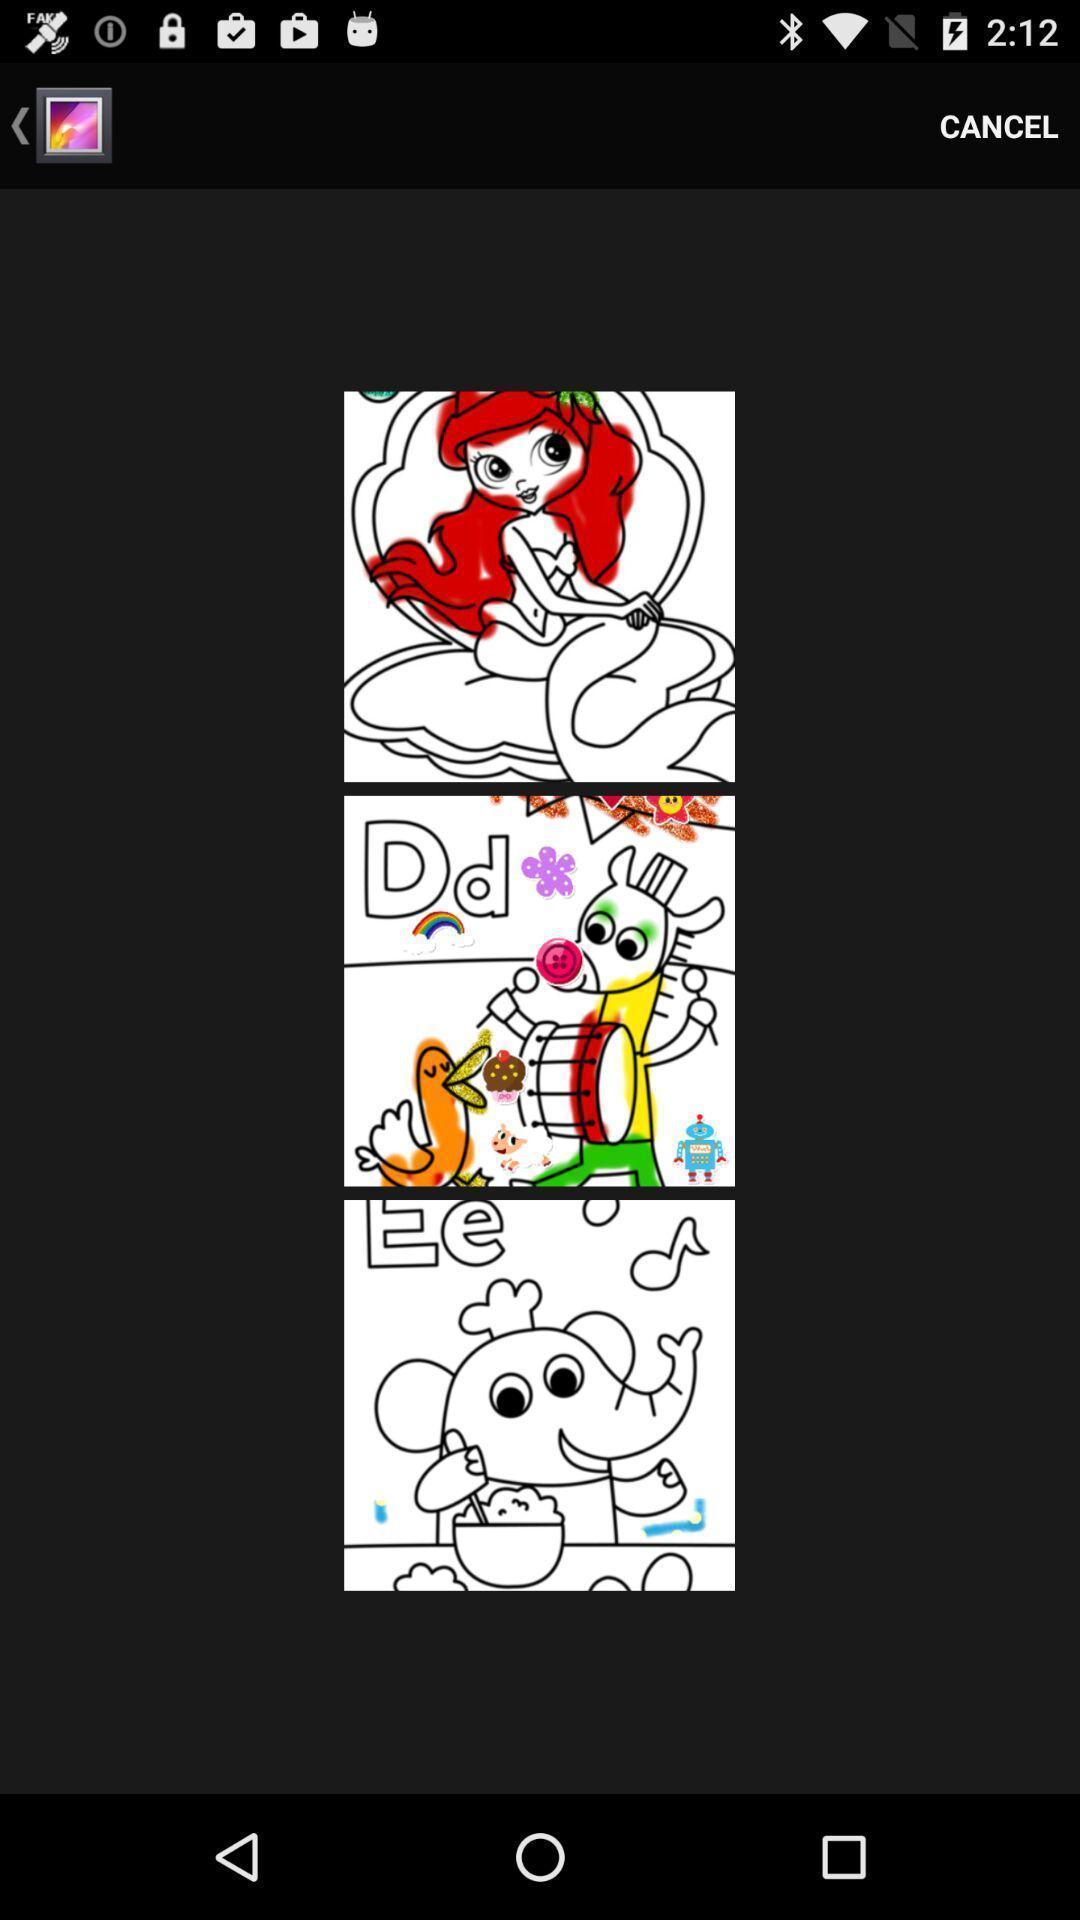Give me a summary of this screen capture. Screen displaying the list of images in a gallery page. 